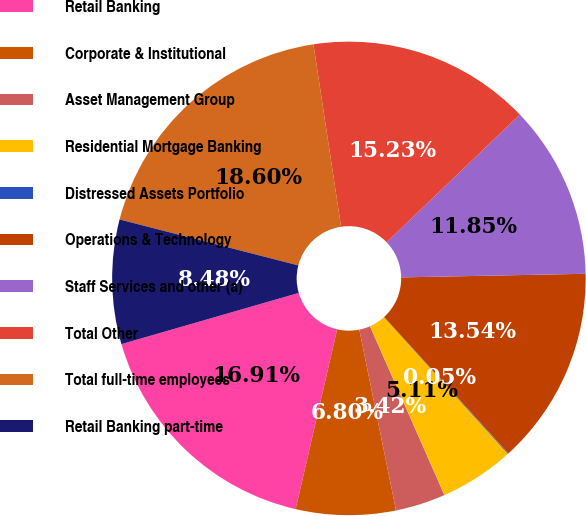<chart> <loc_0><loc_0><loc_500><loc_500><pie_chart><fcel>Retail Banking<fcel>Corporate & Institutional<fcel>Asset Management Group<fcel>Residential Mortgage Banking<fcel>Distressed Assets Portfolio<fcel>Operations & Technology<fcel>Staff Services and other (a)<fcel>Total Other<fcel>Total full-time employees<fcel>Retail Banking part-time<nl><fcel>16.91%<fcel>6.8%<fcel>3.42%<fcel>5.11%<fcel>0.05%<fcel>13.54%<fcel>11.85%<fcel>15.23%<fcel>18.6%<fcel>8.48%<nl></chart> 